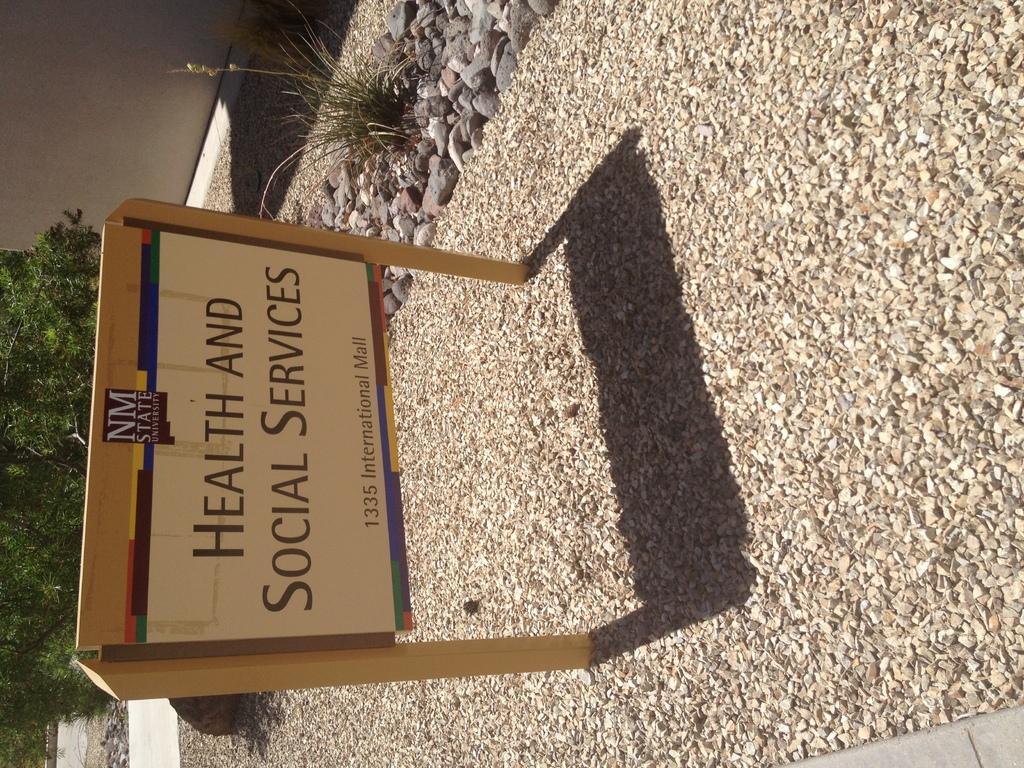How would you summarize this image in a sentence or two? In this image we can see there is a board with text on the stones. At the side there is a plant. And there is a wall, beside the wall there are trees on the ground. 